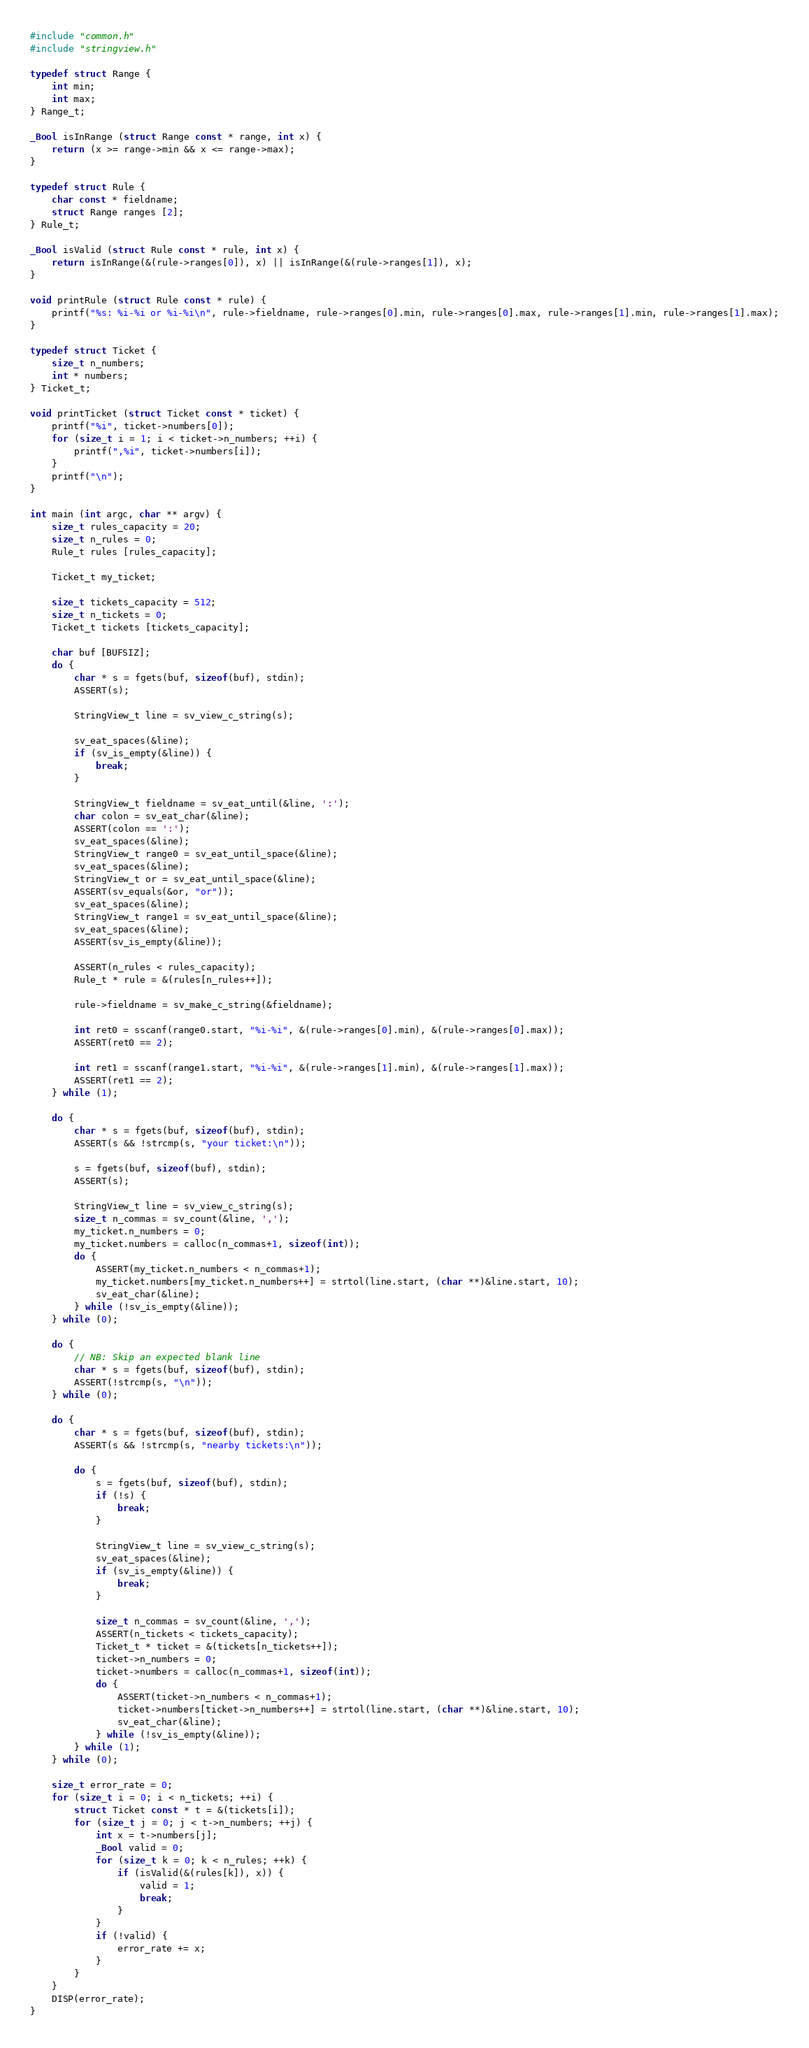Convert code to text. <code><loc_0><loc_0><loc_500><loc_500><_C_>#include "common.h"
#include "stringview.h"

typedef struct Range {
    int min;
    int max;
} Range_t;

_Bool isInRange (struct Range const * range, int x) {
    return (x >= range->min && x <= range->max);
}

typedef struct Rule {
    char const * fieldname;
    struct Range ranges [2];
} Rule_t;

_Bool isValid (struct Rule const * rule, int x) {
    return isInRange(&(rule->ranges[0]), x) || isInRange(&(rule->ranges[1]), x);
}

void printRule (struct Rule const * rule) {
    printf("%s: %i-%i or %i-%i\n", rule->fieldname, rule->ranges[0].min, rule->ranges[0].max, rule->ranges[1].min, rule->ranges[1].max);
}

typedef struct Ticket {
    size_t n_numbers;
    int * numbers;
} Ticket_t;

void printTicket (struct Ticket const * ticket) {
    printf("%i", ticket->numbers[0]);
    for (size_t i = 1; i < ticket->n_numbers; ++i) {
        printf(",%i", ticket->numbers[i]);
    }
    printf("\n");
}

int main (int argc, char ** argv) {
    size_t rules_capacity = 20;
    size_t n_rules = 0;
    Rule_t rules [rules_capacity];

    Ticket_t my_ticket;

    size_t tickets_capacity = 512;
    size_t n_tickets = 0;
    Ticket_t tickets [tickets_capacity];

    char buf [BUFSIZ];
    do {
        char * s = fgets(buf, sizeof(buf), stdin);
        ASSERT(s);

        StringView_t line = sv_view_c_string(s);

        sv_eat_spaces(&line);
        if (sv_is_empty(&line)) {
            break;
        }

        StringView_t fieldname = sv_eat_until(&line, ':');
        char colon = sv_eat_char(&line);
        ASSERT(colon == ':');
        sv_eat_spaces(&line);
        StringView_t range0 = sv_eat_until_space(&line);
        sv_eat_spaces(&line);
        StringView_t or = sv_eat_until_space(&line);
        ASSERT(sv_equals(&or, "or"));
        sv_eat_spaces(&line);
        StringView_t range1 = sv_eat_until_space(&line);
        sv_eat_spaces(&line);
        ASSERT(sv_is_empty(&line));

        ASSERT(n_rules < rules_capacity);
        Rule_t * rule = &(rules[n_rules++]);

        rule->fieldname = sv_make_c_string(&fieldname);

        int ret0 = sscanf(range0.start, "%i-%i", &(rule->ranges[0].min), &(rule->ranges[0].max));
        ASSERT(ret0 == 2);

        int ret1 = sscanf(range1.start, "%i-%i", &(rule->ranges[1].min), &(rule->ranges[1].max));
        ASSERT(ret1 == 2);
    } while (1);

    do {
        char * s = fgets(buf, sizeof(buf), stdin);
        ASSERT(s && !strcmp(s, "your ticket:\n"));

        s = fgets(buf, sizeof(buf), stdin);
        ASSERT(s);

        StringView_t line = sv_view_c_string(s);
        size_t n_commas = sv_count(&line, ',');
        my_ticket.n_numbers = 0;
        my_ticket.numbers = calloc(n_commas+1, sizeof(int));
        do {
            ASSERT(my_ticket.n_numbers < n_commas+1);
            my_ticket.numbers[my_ticket.n_numbers++] = strtol(line.start, (char **)&line.start, 10);
            sv_eat_char(&line);
        } while (!sv_is_empty(&line));
    } while (0);

    do {
        // NB: Skip an expected blank line
        char * s = fgets(buf, sizeof(buf), stdin);
        ASSERT(!strcmp(s, "\n"));
    } while (0);

    do {
        char * s = fgets(buf, sizeof(buf), stdin);
        ASSERT(s && !strcmp(s, "nearby tickets:\n"));

        do {
            s = fgets(buf, sizeof(buf), stdin);
            if (!s) {
                break;
            }

            StringView_t line = sv_view_c_string(s);
            sv_eat_spaces(&line);
            if (sv_is_empty(&line)) {
                break;
            }

            size_t n_commas = sv_count(&line, ',');
            ASSERT(n_tickets < tickets_capacity);
            Ticket_t * ticket = &(tickets[n_tickets++]);
            ticket->n_numbers = 0;
            ticket->numbers = calloc(n_commas+1, sizeof(int));
            do {
                ASSERT(ticket->n_numbers < n_commas+1);
                ticket->numbers[ticket->n_numbers++] = strtol(line.start, (char **)&line.start, 10);
                sv_eat_char(&line);
            } while (!sv_is_empty(&line));
        } while (1);
    } while (0);

    size_t error_rate = 0;
    for (size_t i = 0; i < n_tickets; ++i) {
        struct Ticket const * t = &(tickets[i]);
        for (size_t j = 0; j < t->n_numbers; ++j) {
            int x = t->numbers[j];
            _Bool valid = 0;
            for (size_t k = 0; k < n_rules; ++k) {
                if (isValid(&(rules[k]), x)) {
                    valid = 1;
                    break;
                }
            }
            if (!valid) {
                error_rate += x;
            }
        }
    }
    DISP(error_rate);
}
</code> 